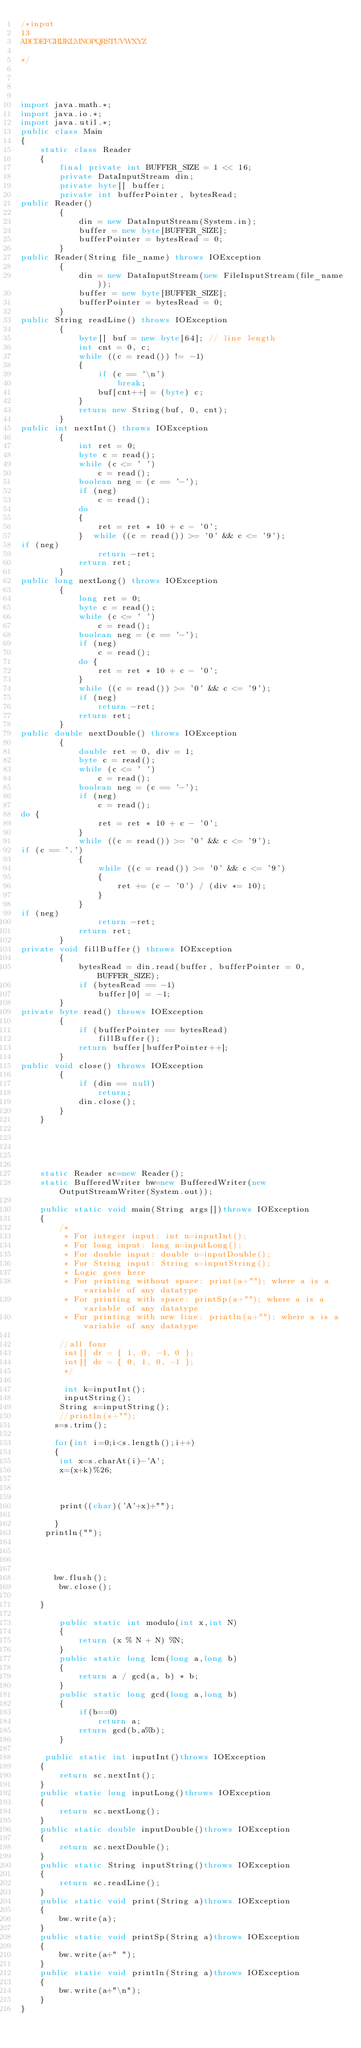Convert code to text. <code><loc_0><loc_0><loc_500><loc_500><_Java_>/*input
13
ABCDEFGHIJKLMNOPQRSTUVWXYZ

*/




import java.math.*;
import java.io.*;
import java.util.*;
public class Main
{
    static class Reader 
    { 
        final private int BUFFER_SIZE = 1 << 16; 
        private DataInputStream din; 
        private byte[] buffer; 
        private int bufferPointer, bytesRead;
public Reader() 
        { 
            din = new DataInputStream(System.in); 
            buffer = new byte[BUFFER_SIZE]; 
            bufferPointer = bytesRead = 0; 
        }
public Reader(String file_name) throws IOException 
        { 
            din = new DataInputStream(new FileInputStream(file_name)); 
            buffer = new byte[BUFFER_SIZE]; 
            bufferPointer = bytesRead = 0; 
        }
public String readLine() throws IOException 
        { 
            byte[] buf = new byte[64]; // line length 
            int cnt = 0, c; 
            while ((c = read()) != -1) 
            { 
                if (c == '\n') 
                    break; 
                buf[cnt++] = (byte) c; 
            } 
            return new String(buf, 0, cnt); 
        }
public int nextInt() throws IOException 
        { 
            int ret = 0; 
            byte c = read(); 
            while (c <= ' ') 
                c = read(); 
            boolean neg = (c == '-'); 
            if (neg) 
                c = read(); 
            do
            { 
                ret = ret * 10 + c - '0'; 
            }  while ((c = read()) >= '0' && c <= '9');
if (neg) 
                return -ret; 
            return ret; 
        }
public long nextLong() throws IOException 
        { 
            long ret = 0; 
            byte c = read(); 
            while (c <= ' ') 
                c = read(); 
            boolean neg = (c == '-'); 
            if (neg) 
                c = read(); 
            do { 
                ret = ret * 10 + c - '0'; 
            } 
            while ((c = read()) >= '0' && c <= '9'); 
            if (neg) 
                return -ret; 
            return ret; 
        }
public double nextDouble() throws IOException 
        { 
            double ret = 0, div = 1; 
            byte c = read(); 
            while (c <= ' ') 
                c = read(); 
            boolean neg = (c == '-'); 
            if (neg) 
                c = read();
do { 
                ret = ret * 10 + c - '0'; 
            } 
            while ((c = read()) >= '0' && c <= '9');
if (c == '.') 
            { 
                while ((c = read()) >= '0' && c <= '9') 
                { 
                    ret += (c - '0') / (div *= 10); 
                } 
            }
if (neg) 
                return -ret; 
            return ret; 
        }
private void fillBuffer() throws IOException 
        { 
            bytesRead = din.read(buffer, bufferPointer = 0, BUFFER_SIZE); 
            if (bytesRead == -1) 
                buffer[0] = -1; 
        }
private byte read() throws IOException 
        { 
            if (bufferPointer == bytesRead) 
                fillBuffer(); 
            return buffer[bufferPointer++]; 
        }
public void close() throws IOException 
        { 
            if (din == null) 
                return; 
            din.close(); 
        } 
    } 





    static Reader sc=new Reader();
    static BufferedWriter bw=new BufferedWriter(new OutputStreamWriter(System.out));

    public static void main(String args[])throws IOException
    {
        /*
         * For integer input: int n=inputInt();
         * For long input: long n=inputLong();
         * For double input: double n=inputDouble();
         * For String input: String s=inputString();
         * Logic goes here
         * For printing without space: print(a+""); where a is a variable of any datatype
         * For printing with space: printSp(a+""); where a is a variable of any datatype
         * For printing with new line: println(a+""); where a is a variable of any datatype
        
        //all four
         int[] dr = { 1, 0, -1, 0 };
         int[] dc = { 0, 1, 0, -1 };
         */

         int k=inputInt();
         inputString();
        String s=inputString();
        //println(s+"");
       s=s.trim();

       for(int i=0;i<s.length();i++)
       {
       	int x=s.charAt(i)-'A';
       	x=(x+k)%26;

       	

       	print((char)('A'+x)+"");

       }
     println("");
    
      


       bw.flush();
        bw.close();

    }

		public static int modulo(int x,int N)
		{
    		return (x % N + N) %N;
		}
		public static long lcm(long a,long b)
        {    
            return a / gcd(a, b) * b;
        }
        public static long gcd(long a,long b)
        {
            if(b==0)
                return a;
            return gcd(b,a%b);
        }

     public static int inputInt()throws IOException
    {
        return sc.nextInt();
    }
    public static long inputLong()throws IOException
    {
        return sc.nextLong();
    }
    public static double inputDouble()throws IOException
    {
        return sc.nextDouble();
    }
    public static String inputString()throws IOException
    {
        return sc.readLine();
    }
    public static void print(String a)throws IOException
    {
        bw.write(a);
    }
    public static void printSp(String a)throws IOException
    {
        bw.write(a+" ");
    }
    public static void println(String a)throws IOException
    {
        bw.write(a+"\n");
    }
}</code> 